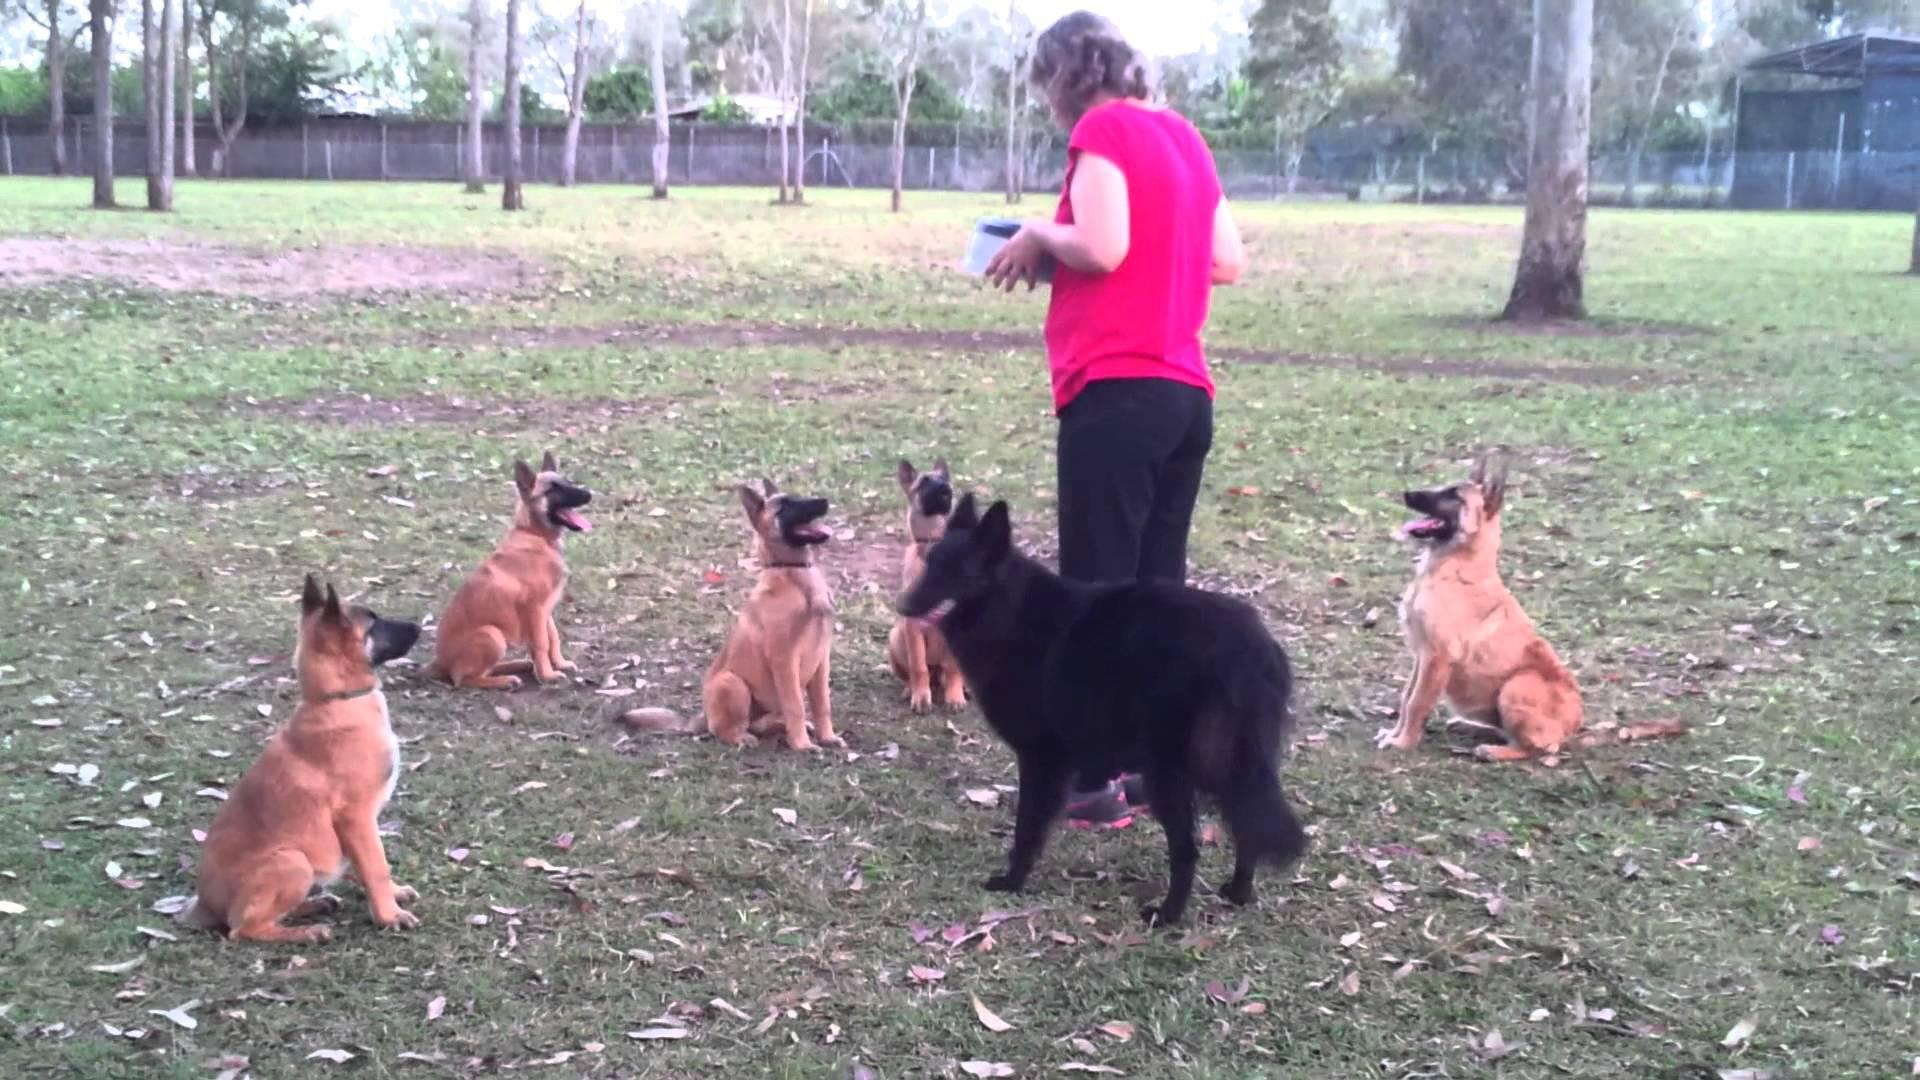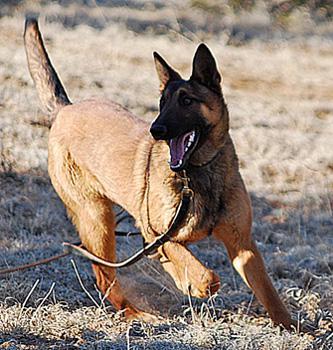The first image is the image on the left, the second image is the image on the right. Considering the images on both sides, is "There is exactly one human interacting with a dog." valid? Answer yes or no. Yes. 